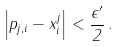Convert formula to latex. <formula><loc_0><loc_0><loc_500><loc_500>\left | p _ { j , i } - x _ { i } ^ { j } \right | < \frac { \epsilon ^ { \prime } } { 2 } \, .</formula> 